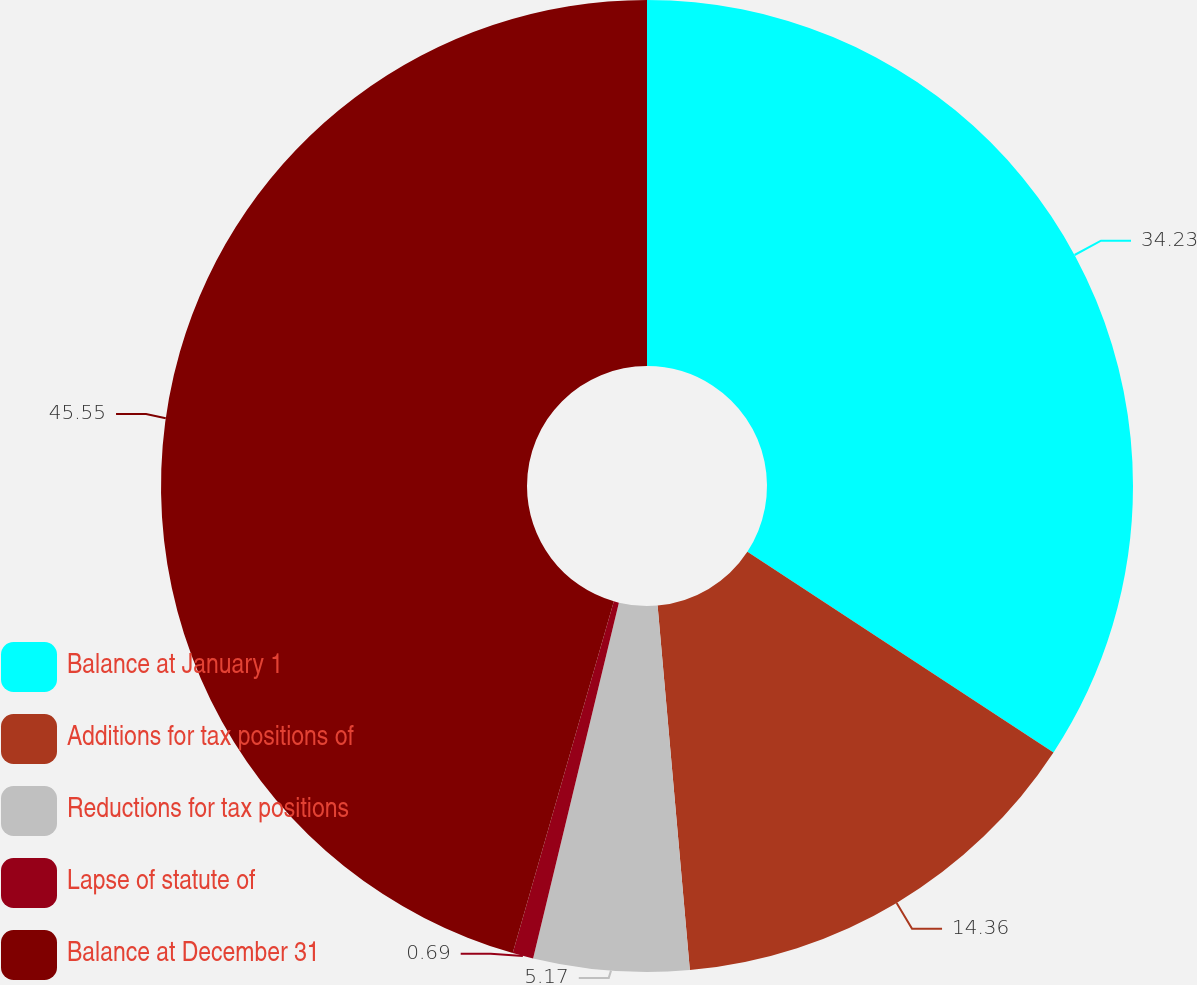Convert chart. <chart><loc_0><loc_0><loc_500><loc_500><pie_chart><fcel>Balance at January 1<fcel>Additions for tax positions of<fcel>Reductions for tax positions<fcel>Lapse of statute of<fcel>Balance at December 31<nl><fcel>34.23%<fcel>14.36%<fcel>5.17%<fcel>0.69%<fcel>45.54%<nl></chart> 